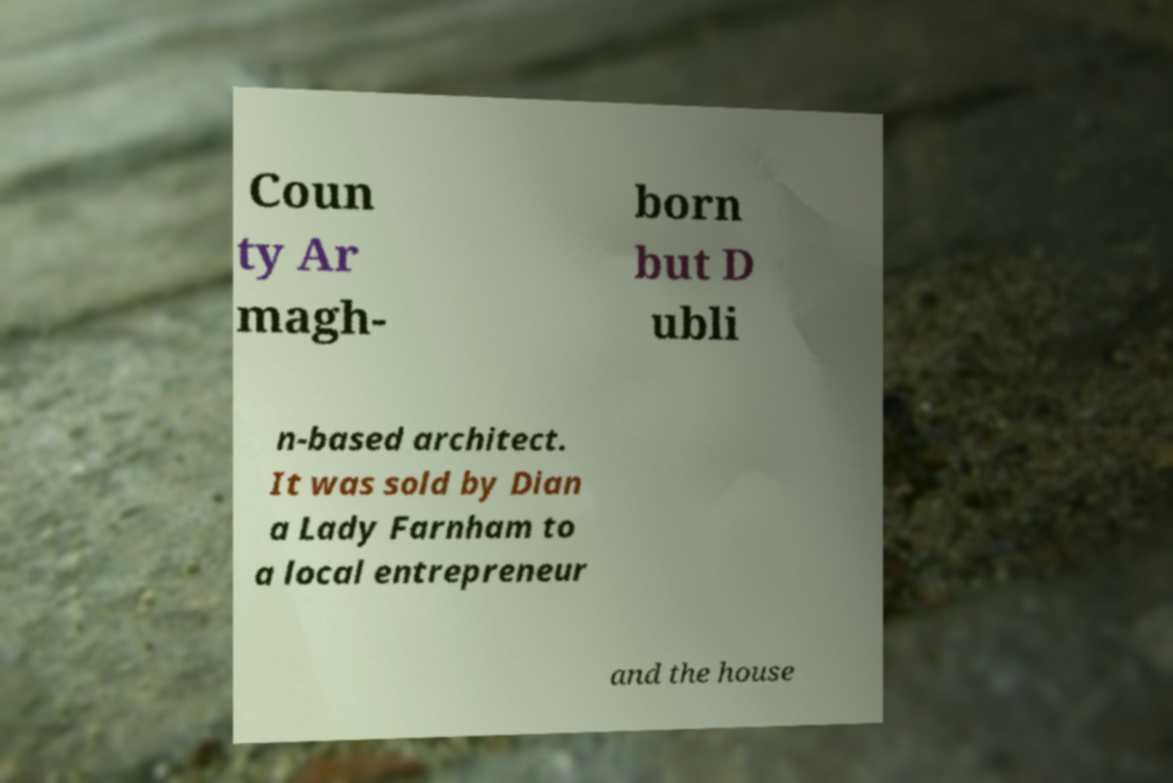What messages or text are displayed in this image? I need them in a readable, typed format. Coun ty Ar magh- born but D ubli n-based architect. It was sold by Dian a Lady Farnham to a local entrepreneur and the house 